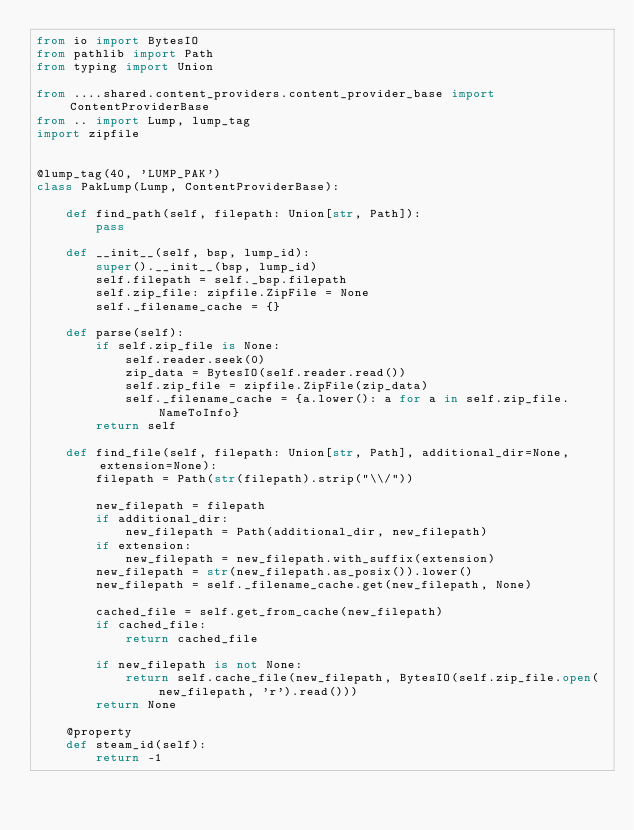Convert code to text. <code><loc_0><loc_0><loc_500><loc_500><_Python_>from io import BytesIO
from pathlib import Path
from typing import Union

from ....shared.content_providers.content_provider_base import ContentProviderBase
from .. import Lump, lump_tag
import zipfile


@lump_tag(40, 'LUMP_PAK')
class PakLump(Lump, ContentProviderBase):

    def find_path(self, filepath: Union[str, Path]):
        pass

    def __init__(self, bsp, lump_id):
        super().__init__(bsp, lump_id)
        self.filepath = self._bsp.filepath
        self.zip_file: zipfile.ZipFile = None
        self._filename_cache = {}

    def parse(self):
        if self.zip_file is None:
            self.reader.seek(0)
            zip_data = BytesIO(self.reader.read())
            self.zip_file = zipfile.ZipFile(zip_data)
            self._filename_cache = {a.lower(): a for a in self.zip_file.NameToInfo}
        return self

    def find_file(self, filepath: Union[str, Path], additional_dir=None, extension=None):
        filepath = Path(str(filepath).strip("\\/"))

        new_filepath = filepath
        if additional_dir:
            new_filepath = Path(additional_dir, new_filepath)
        if extension:
            new_filepath = new_filepath.with_suffix(extension)
        new_filepath = str(new_filepath.as_posix()).lower()
        new_filepath = self._filename_cache.get(new_filepath, None)

        cached_file = self.get_from_cache(new_filepath)
        if cached_file:
            return cached_file

        if new_filepath is not None:
            return self.cache_file(new_filepath, BytesIO(self.zip_file.open(new_filepath, 'r').read()))
        return None

    @property
    def steam_id(self):
        return -1
</code> 